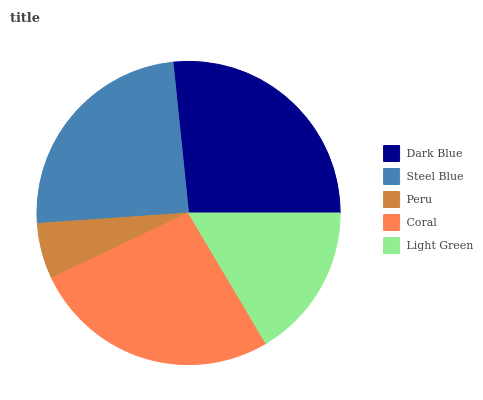Is Peru the minimum?
Answer yes or no. Yes. Is Dark Blue the maximum?
Answer yes or no. Yes. Is Steel Blue the minimum?
Answer yes or no. No. Is Steel Blue the maximum?
Answer yes or no. No. Is Dark Blue greater than Steel Blue?
Answer yes or no. Yes. Is Steel Blue less than Dark Blue?
Answer yes or no. Yes. Is Steel Blue greater than Dark Blue?
Answer yes or no. No. Is Dark Blue less than Steel Blue?
Answer yes or no. No. Is Steel Blue the high median?
Answer yes or no. Yes. Is Steel Blue the low median?
Answer yes or no. Yes. Is Light Green the high median?
Answer yes or no. No. Is Coral the low median?
Answer yes or no. No. 